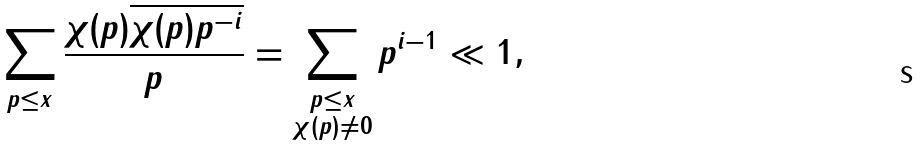<formula> <loc_0><loc_0><loc_500><loc_500>\sum _ { p \leq x } \frac { \chi ( p ) \overline { \chi ( p ) p ^ { - i } } } { p } = \sum _ { \substack { p \leq x \\ \chi ( p ) \ne 0 } } p ^ { i - 1 } \ll 1 ,</formula> 